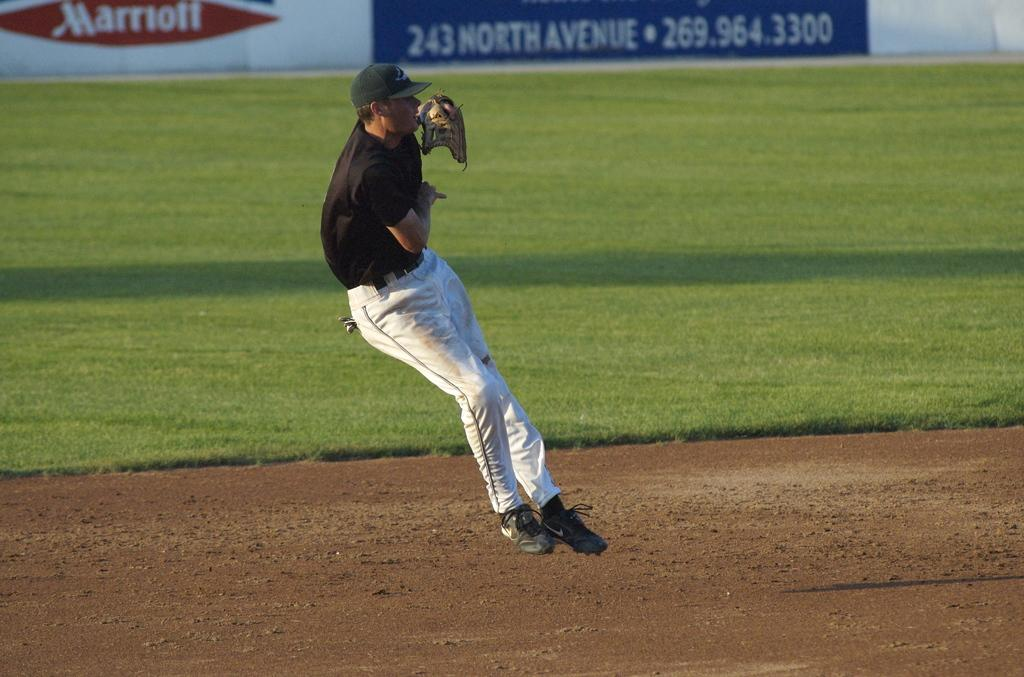<image>
Write a terse but informative summary of the picture. A shortstop makes a play at a baseball game with a banner advertising Marriott in the background. 